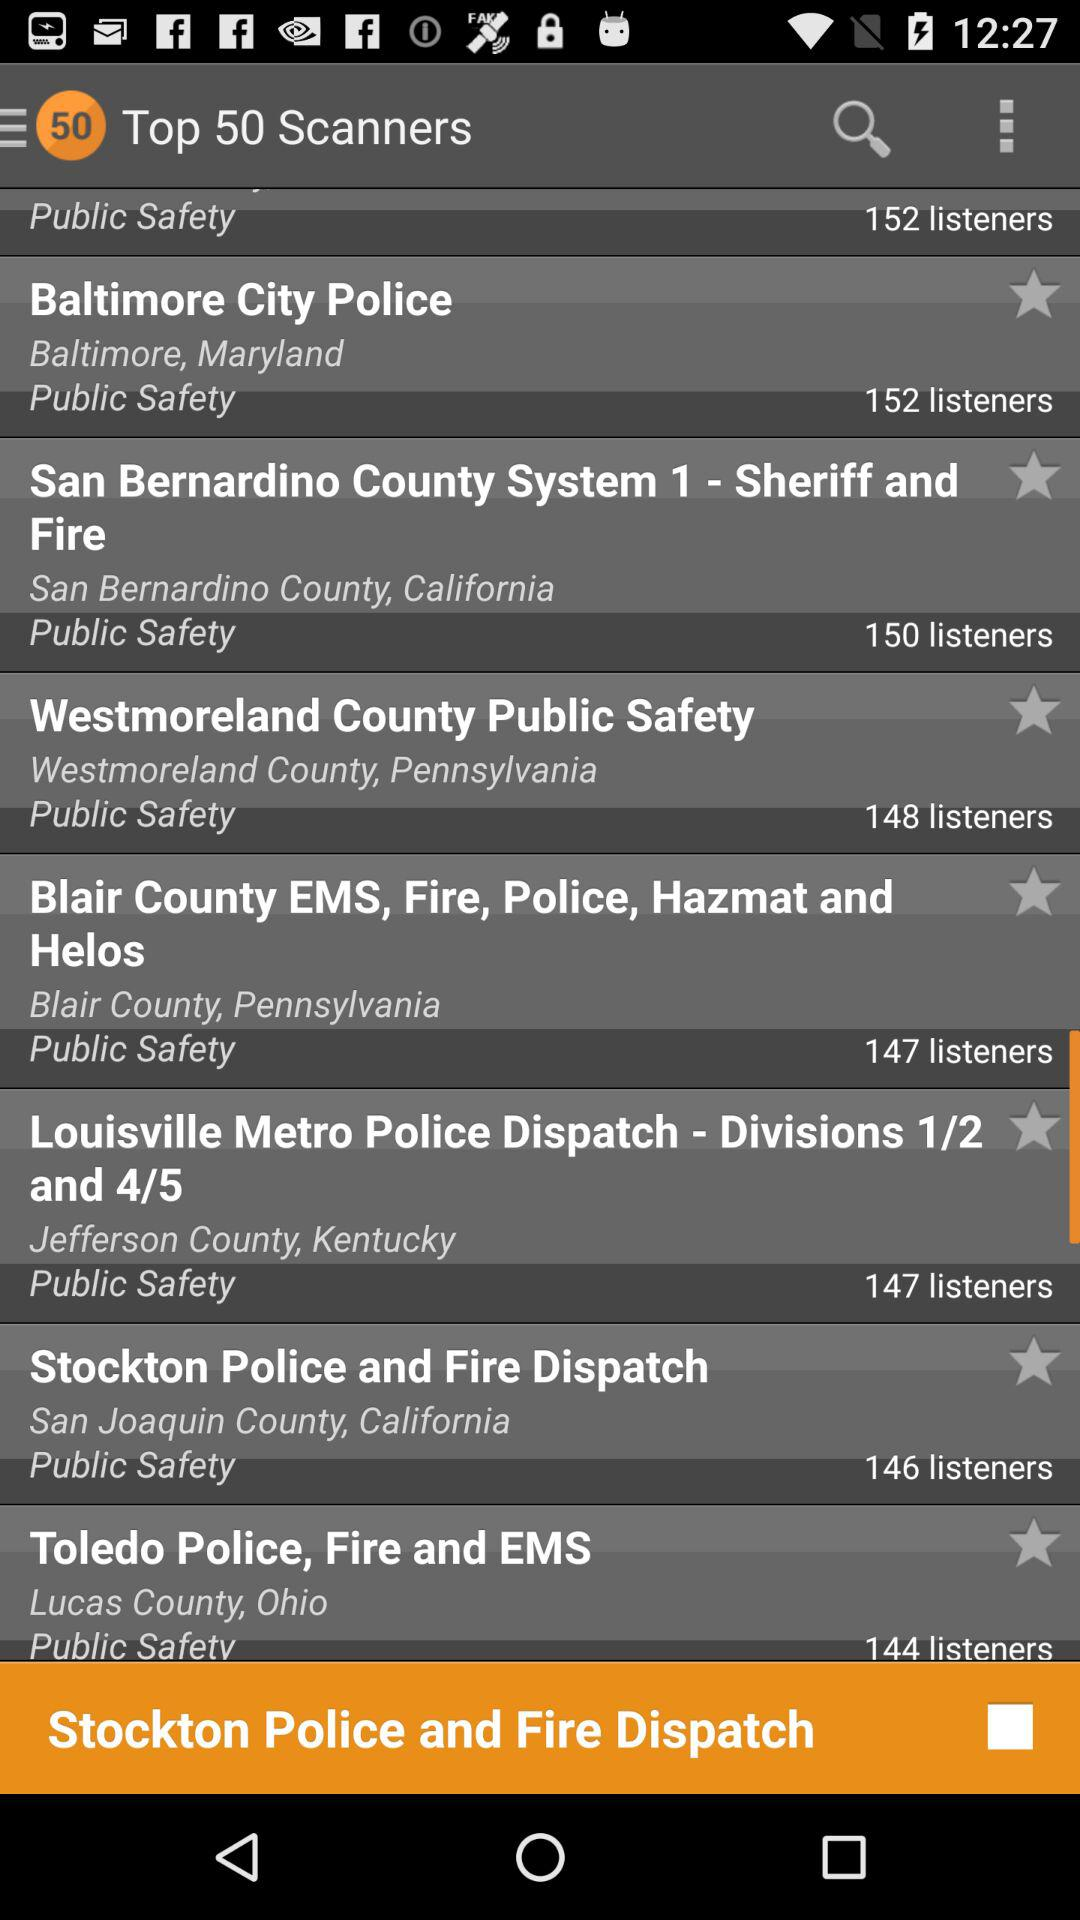How many listeners are there in "Toledo Police, Fire and EMS"? There are 144 listeners. 